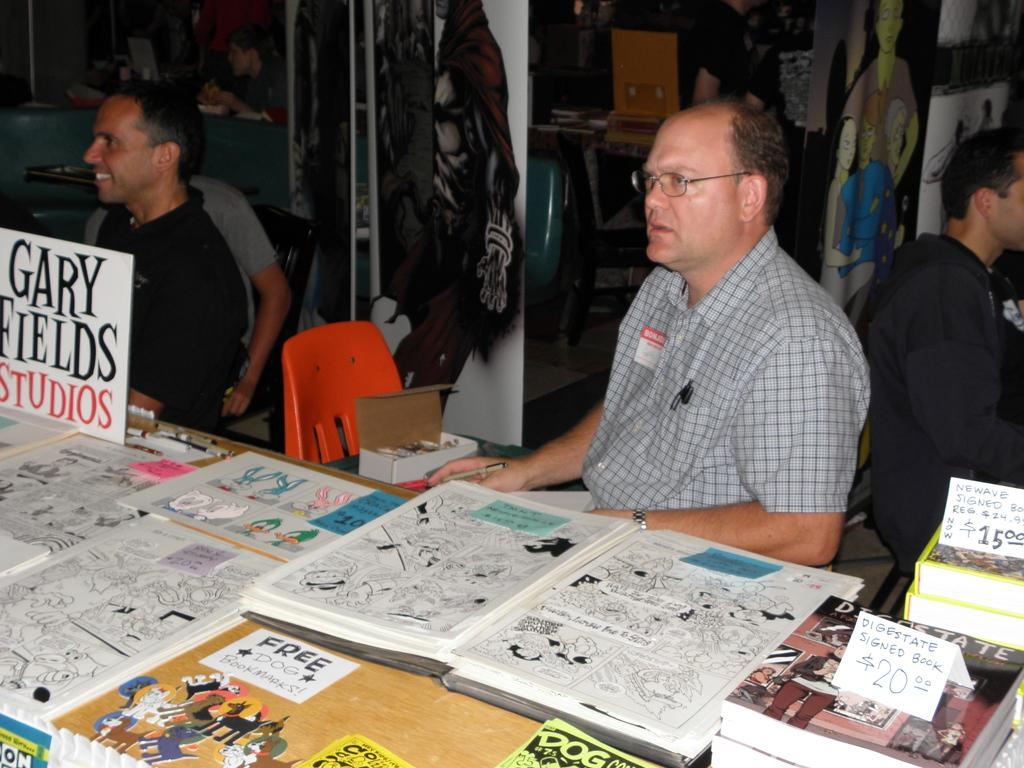<image>
Offer a succinct explanation of the picture presented. A man is sitting at a booth with comics and a price tag that says $15. 